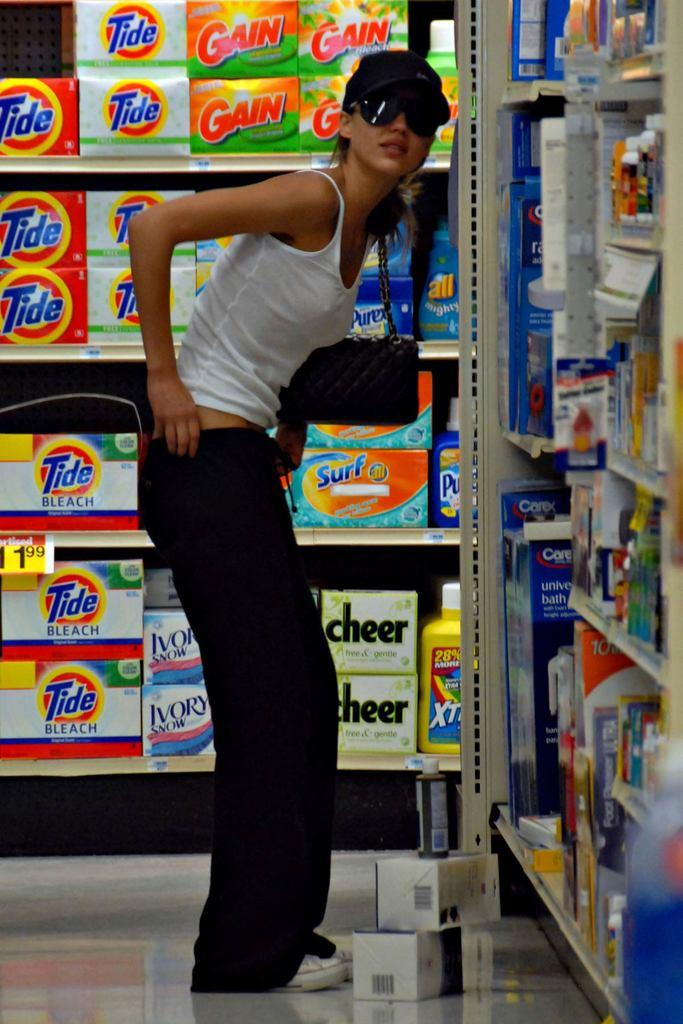Provide a one-sentence caption for the provided image. A woman, standing in a cleaning supplies aisle, pulling up her black pants. 